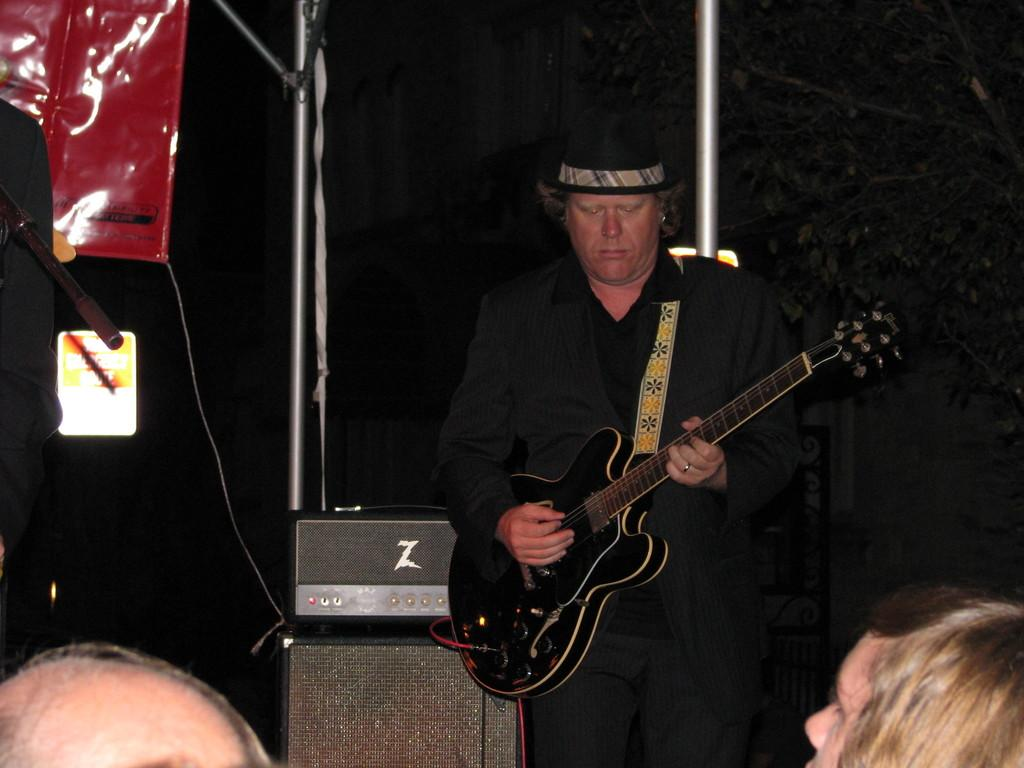What is the man in the image doing? The man is playing a guitar. How many people are seated in the image? There are two people seated in the image. What type of waves can be seen in the image? There are no waves present in the image. Who is the man's friend in the image? The provided facts do not mention any friends or relationships between the people in the image. 